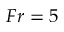<formula> <loc_0><loc_0><loc_500><loc_500>F r = 5</formula> 